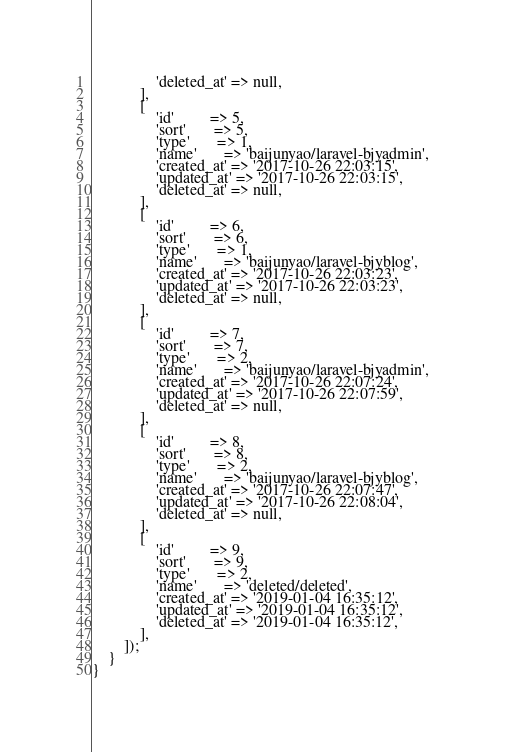<code> <loc_0><loc_0><loc_500><loc_500><_PHP_>                'deleted_at' => null,
            ],
            [
                'id'         => 5,
                'sort'       => 5,
                'type'       => 1,
                'name'       => 'baijunyao/laravel-bjyadmin',
                'created_at' => '2017-10-26 22:03:15',
                'updated_at' => '2017-10-26 22:03:15',
                'deleted_at' => null,
            ],
            [
                'id'         => 6,
                'sort'       => 6,
                'type'       => 1,
                'name'       => 'baijunyao/laravel-bjyblog',
                'created_at' => '2017-10-26 22:03:23',
                'updated_at' => '2017-10-26 22:03:23',
                'deleted_at' => null,
            ],
            [
                'id'         => 7,
                'sort'       => 7,
                'type'       => 2,
                'name'       => 'baijunyao/laravel-bjyadmin',
                'created_at' => '2017-10-26 22:07:24',
                'updated_at' => '2017-10-26 22:07:59',
                'deleted_at' => null,
            ],
            [
                'id'         => 8,
                'sort'       => 8,
                'type'       => 2,
                'name'       => 'baijunyao/laravel-bjyblog',
                'created_at' => '2017-10-26 22:07:47',
                'updated_at' => '2017-10-26 22:08:04',
                'deleted_at' => null,
            ],
            [
                'id'         => 9,
                'sort'       => 9,
                'type'       => 2,
                'name'       => 'deleted/deleted',
                'created_at' => '2019-01-04 16:35:12',
                'updated_at' => '2019-01-04 16:35:12',
                'deleted_at' => '2019-01-04 16:35:12',
            ],
        ]);
    }
}
</code> 